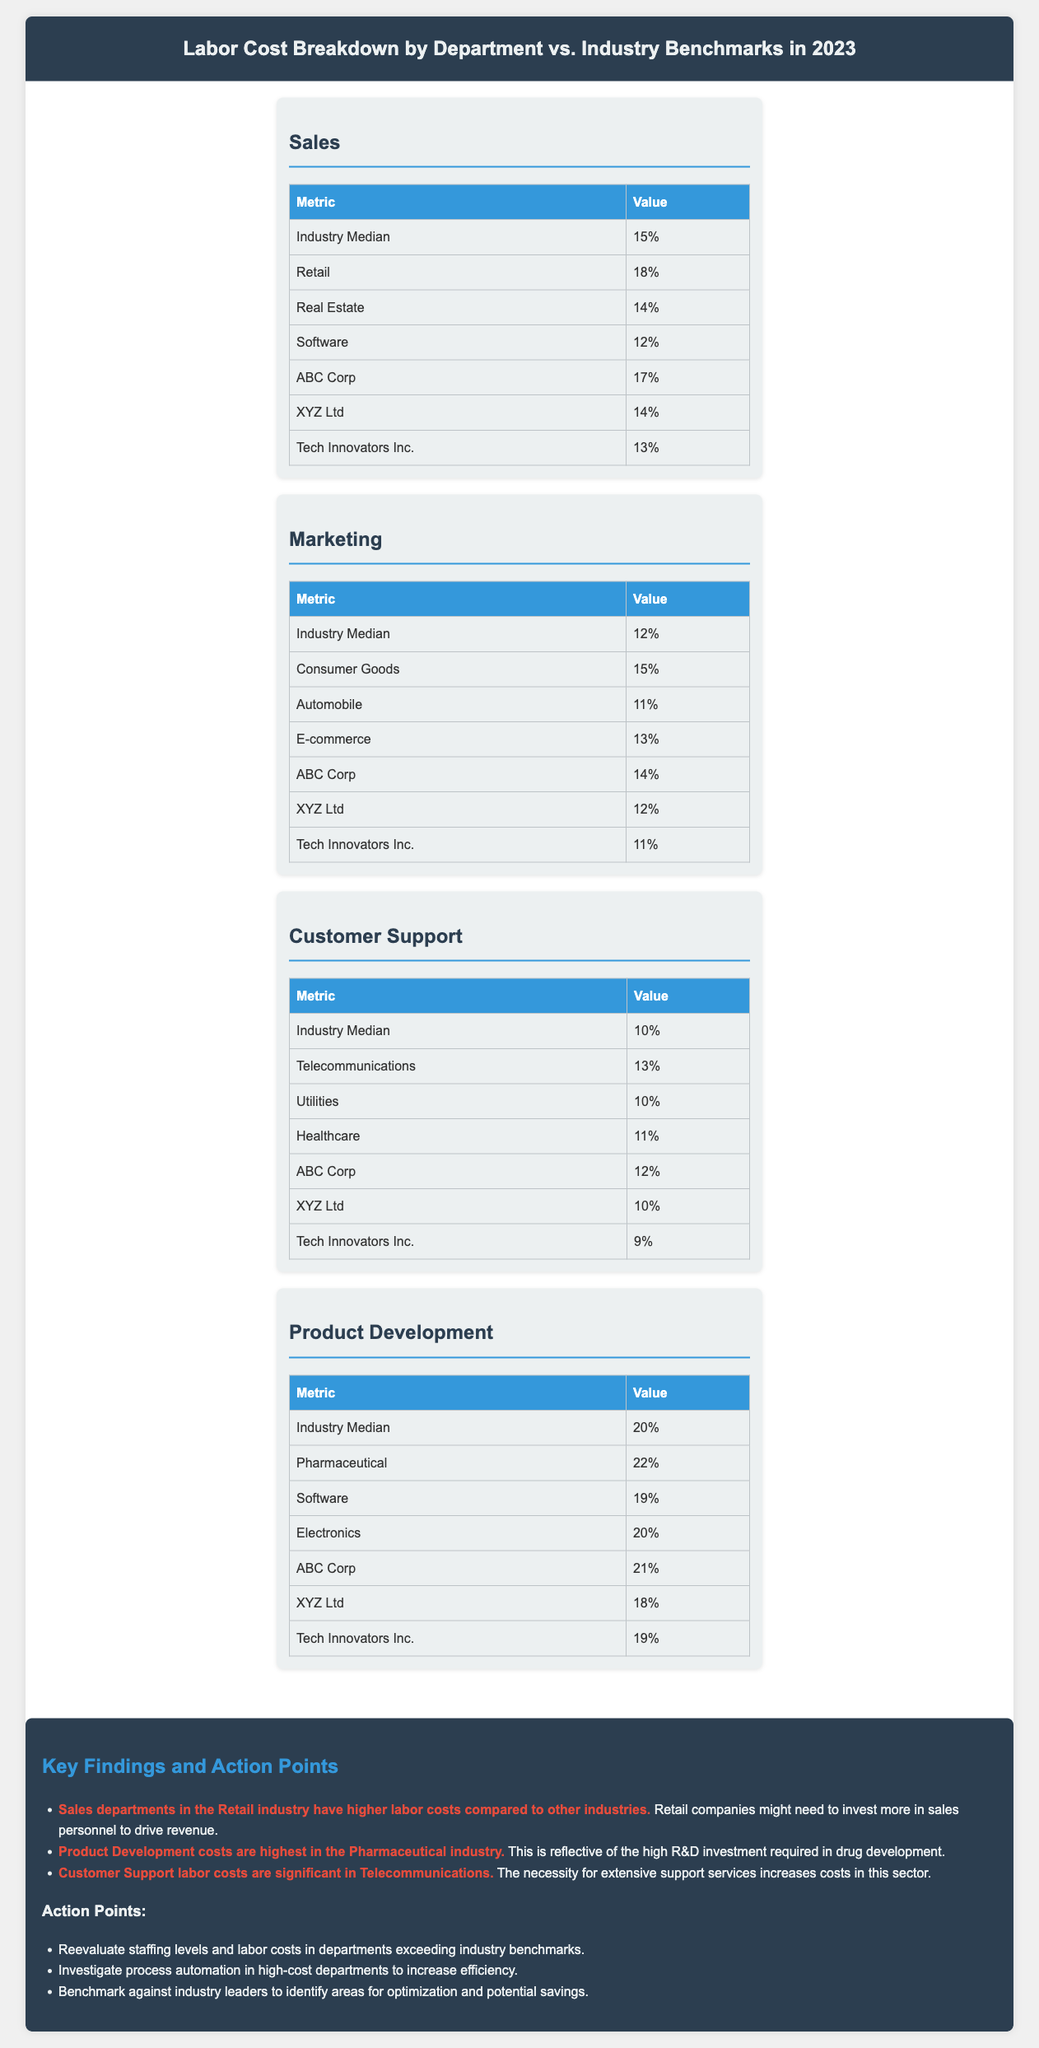What is the industry median labor cost for the Sales department? The industry median for the Sales department is listed in the document, which is 15%.
Answer: 15% What percentage does ABC Corp spend on Marketing labor costs? ABC Corp's labor cost for Marketing is specifically noted, which is 14%.
Answer: 14% Which department has the highest industry median labor cost? The document indicates that the Product Development department has the highest industry median, at 20%.
Answer: 20% What is the labor cost percentage for Customer Support at XYZ Ltd? The document lists the labor cost for Customer Support at XYZ Ltd as 10%.
Answer: 10% Which industry shows the highest labor cost in Product Development? From the document, the Pharmaceutical industry shows the highest labor cost in Product Development at 22%.
Answer: 22% Is ABC Corp's labor cost in the Sales department above or below the industry median? By comparing ABC Corp's sales labor cost of 17% to the industry median of 15%, it is determined that it is above.
Answer: Above What action point suggests improving efficiency in high-cost departments? One of the action points recommends investigating process automation in high-cost departments to increase efficiency.
Answer: Investigate process automation What does the document suggest regarding staffing levels in departments? The document advises reevaluating staffing levels in departments exceeding industry benchmarks.
Answer: Reevaluate staffing levels 